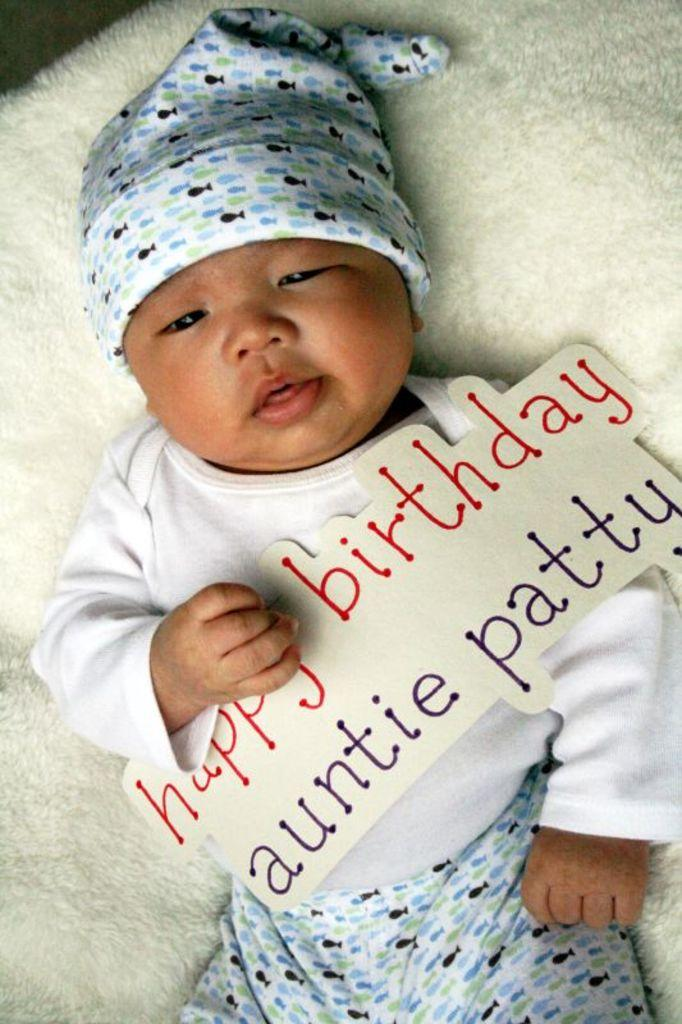Who is the main subject in the picture? There is a child in the picture. What is the child lying on? The child is lying on a white color cloth. What is the child wearing on their head? The child is wearing a cap. What is the child holding in their hand? The child is holding a paper. What can be seen on the paper the child is holding? The paper has something written on it. What type of rings can be seen on the child's fingers in the image? There are no rings visible on the child's fingers in the image. What kind of system is the child using to write on the paper? The image does not show the child writing on the paper, nor does it depict any system for writing. 